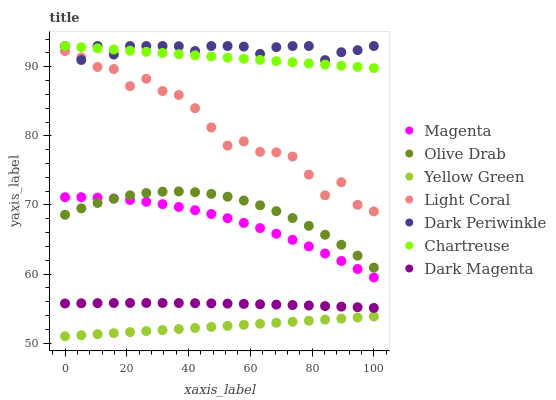Does Yellow Green have the minimum area under the curve?
Answer yes or no. Yes. Does Dark Periwinkle have the maximum area under the curve?
Answer yes or no. Yes. Does Light Coral have the minimum area under the curve?
Answer yes or no. No. Does Light Coral have the maximum area under the curve?
Answer yes or no. No. Is Yellow Green the smoothest?
Answer yes or no. Yes. Is Light Coral the roughest?
Answer yes or no. Yes. Is Chartreuse the smoothest?
Answer yes or no. No. Is Chartreuse the roughest?
Answer yes or no. No. Does Yellow Green have the lowest value?
Answer yes or no. Yes. Does Light Coral have the lowest value?
Answer yes or no. No. Does Dark Periwinkle have the highest value?
Answer yes or no. Yes. Does Light Coral have the highest value?
Answer yes or no. No. Is Dark Magenta less than Light Coral?
Answer yes or no. Yes. Is Magenta greater than Dark Magenta?
Answer yes or no. Yes. Does Olive Drab intersect Magenta?
Answer yes or no. Yes. Is Olive Drab less than Magenta?
Answer yes or no. No. Is Olive Drab greater than Magenta?
Answer yes or no. No. Does Dark Magenta intersect Light Coral?
Answer yes or no. No. 